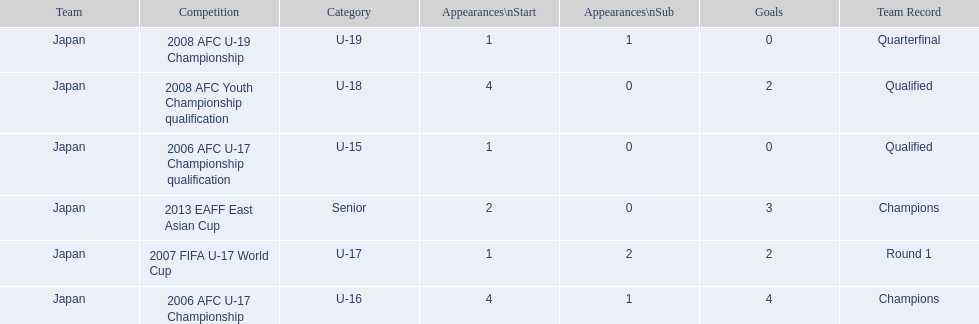Write the full table. {'header': ['Team', 'Competition', 'Category', 'Appearances\\nStart', 'Appearances\\nSub', 'Goals', 'Team Record'], 'rows': [['Japan', '2008 AFC U-19 Championship', 'U-19', '1', '1', '0', 'Quarterfinal'], ['Japan', '2008 AFC Youth Championship qualification', 'U-18', '4', '0', '2', 'Qualified'], ['Japan', '2006 AFC U-17 Championship qualification', 'U-15', '1', '0', '0', 'Qualified'], ['Japan', '2013 EAFF East Asian Cup', 'Senior', '2', '0', '3', 'Champions'], ['Japan', '2007 FIFA U-17 World Cup', 'U-17', '1', '2', '2', 'Round 1'], ['Japan', '2006 AFC U-17 Championship', 'U-16', '4', '1', '4', 'Champions']]} Which competitions has yoichiro kakitani participated in? 2006 AFC U-17 Championship qualification, 2006 AFC U-17 Championship, 2007 FIFA U-17 World Cup, 2008 AFC Youth Championship qualification, 2008 AFC U-19 Championship, 2013 EAFF East Asian Cup. How many times did he start during each competition? 1, 4, 1, 4, 1, 2. How many goals did he score during those? 0, 4, 2, 2, 0, 3. And during which competition did yoichiro achieve the most starts and goals? 2006 AFC U-17 Championship. 